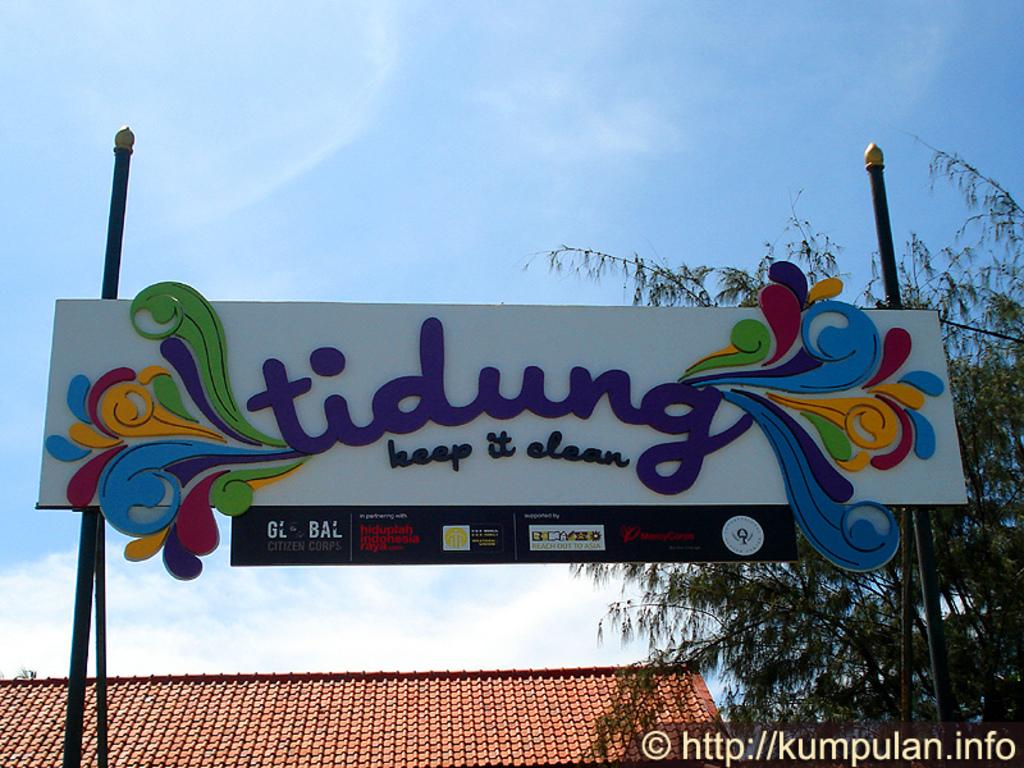<image>
Render a clear and concise summary of the photo. A large colorful billboard contains the slogan keep it clean. 